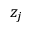Convert formula to latex. <formula><loc_0><loc_0><loc_500><loc_500>z _ { j }</formula> 